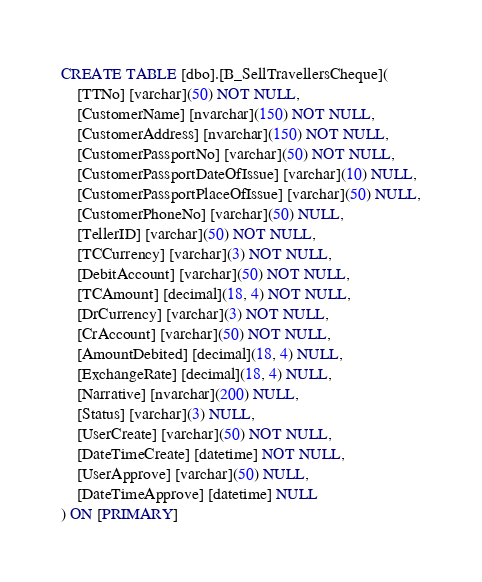<code> <loc_0><loc_0><loc_500><loc_500><_SQL_>CREATE TABLE [dbo].[B_SellTravellersCheque](
	[TTNo] [varchar](50) NOT NULL,
	[CustomerName] [nvarchar](150) NOT NULL,
	[CustomerAddress] [nvarchar](150) NOT NULL,
	[CustomerPassportNo] [varchar](50) NOT NULL,
	[CustomerPassportDateOfIssue] [varchar](10) NULL,
	[CustomerPassportPlaceOfIssue] [varchar](50) NULL,
	[CustomerPhoneNo] [varchar](50) NULL,
	[TellerID] [varchar](50) NOT NULL,
	[TCCurrency] [varchar](3) NOT NULL,
	[DebitAccount] [varchar](50) NOT NULL,
	[TCAmount] [decimal](18, 4) NOT NULL,
	[DrCurrency] [varchar](3) NOT NULL,
	[CrAccount] [varchar](50) NOT NULL,
	[AmountDebited] [decimal](18, 4) NULL,
	[ExchangeRate] [decimal](18, 4) NULL,
	[Narrative] [nvarchar](200) NULL,
	[Status] [varchar](3) NULL,
	[UserCreate] [varchar](50) NOT NULL,
	[DateTimeCreate] [datetime] NOT NULL,
	[UserApprove] [varchar](50) NULL,
	[DateTimeApprove] [datetime] NULL
) ON [PRIMARY]</code> 